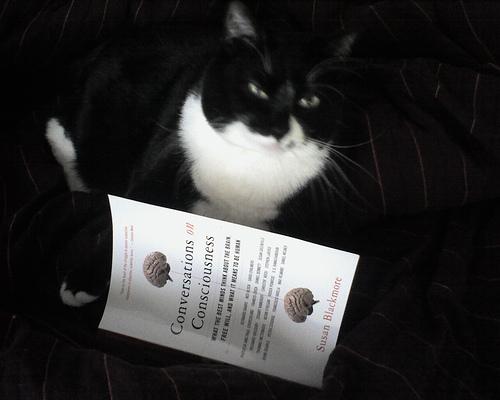What name can be found on the photo?
Concise answer only. Susan blackmore. What does the cat appear to be doing?
Keep it brief. Reading. Is this photo in black and white?
Give a very brief answer. Yes. 